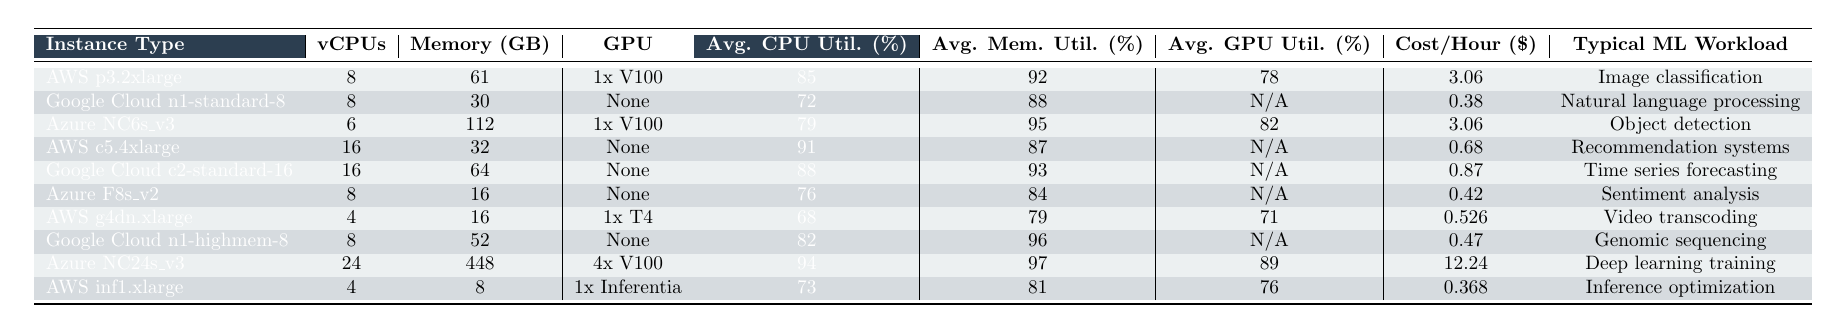What is the instance type with the highest average CPU utilization? By reviewing the "Avg. CPU Utilization (%)" column, the "AWS c5.4xlarge" has the highest value of 91%.
Answer: AWS c5.4xlarge Which instance type has the lowest cost per hour? The "Cost per Hour ($)" column indicates that "Google Cloud n1-standard-8" has the lowest cost at $0.38 per hour.
Answer: Google Cloud n1-standard-8 Is there an instance type that has both GPU and high memory available? By examining the table, "Azure NC24s_v3" stands out as it has 4 GPUs and 448 GB Memory, confirming the statement is true.
Answer: Yes How many instance types have an average memory utilization of over 90%? Reviewing the "Avg. Memory Utilization (%)", there are four instance types: "AWS p3.2xlarge", "Azure NC6s_v3", "Google Cloud c2-standard-16", and "Azure NC24s_v3", all exceeding 90%.
Answer: 4 What is the average number of vCPUs for instances that utilize GPUs? Instances with GPUs are "AWS p3.2xlarge", "Azure NC6s_v3", "AWS g4dn.xlarge", "Azure NC24s_v3", and "AWS inf1.xlarge". Their vCPUs are 8, 6, 4, 24, and 4, respectively. The sum is 46 and dividing by 5 gives an average of 9.2 vCPUs.
Answer: 9.2 Which cloud provider has the highest-cost ML workload instance? "Azure NC24s_v3" at $12.24 is the highest from the "Cost per Hour ($)" column, which is linked to Azure.
Answer: Azure How does the average GPU utilization for the "AWS g4dn.xlarge" compare to "Azure NC24s_v3"? The average GPU utilization for "AWS g4dn.xlarge" is 71% and for "Azure NC24s_v3" is 89%. Therefore, "AWS g4dn.xlarge" has 18% lower GPU utilization than "Azure NC24s_v3".
Answer: 18% lower What is the total average CPU utilization of all instances listed in the table? Sum the values from "Avg. CPU Utilization (%)": 85 + 72 + 79 + 91 + 88 + 76 + 68 + 82 + 94 + 73 =  80.6%. To get the average, divide by 10, giving an overall average CPU utilization of 80.6%.
Answer: 80.6% Which instance type is primarily used for object detection? Looking at the "Typical ML Workload" column, "Azure NC6s_v3" is defined for object detection.
Answer: Azure NC6s_v3 Is there any instance type that does not utilize a GPU? Checking the "GPU" column, "Google Cloud n1-standard-8", "AWS c5.4xlarge", "Google Cloud c2-standard-16", "Azure F8s_v2", and "Google Cloud n1-highmem-8" do not use a GPU, confirming there are multiple instances without GPU.
Answer: Yes 